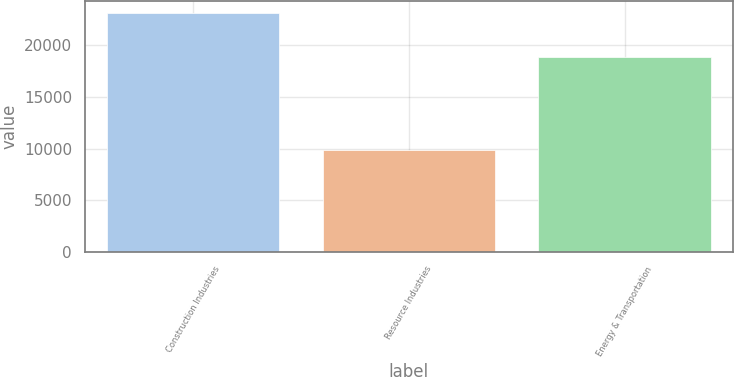<chart> <loc_0><loc_0><loc_500><loc_500><bar_chart><fcel>Construction Industries<fcel>Resource Industries<fcel>Energy & Transportation<nl><fcel>23116<fcel>9888<fcel>18832<nl></chart> 